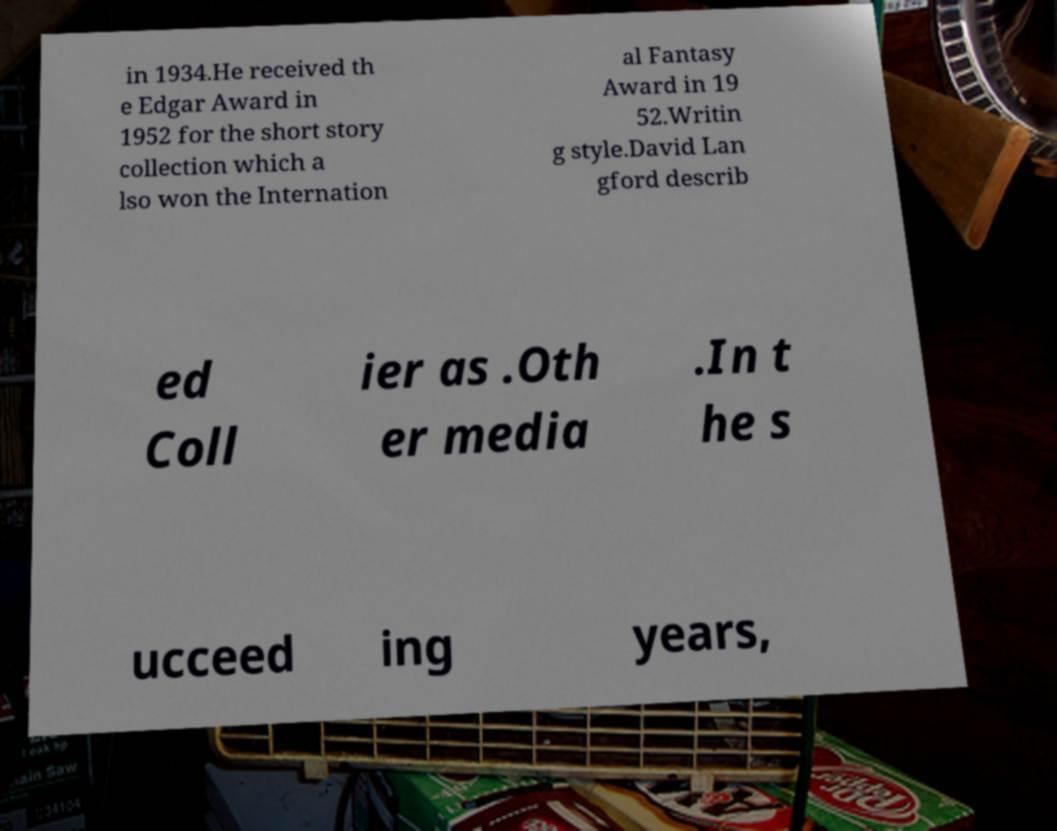Could you assist in decoding the text presented in this image and type it out clearly? in 1934.He received th e Edgar Award in 1952 for the short story collection which a lso won the Internation al Fantasy Award in 19 52.Writin g style.David Lan gford describ ed Coll ier as .Oth er media .In t he s ucceed ing years, 